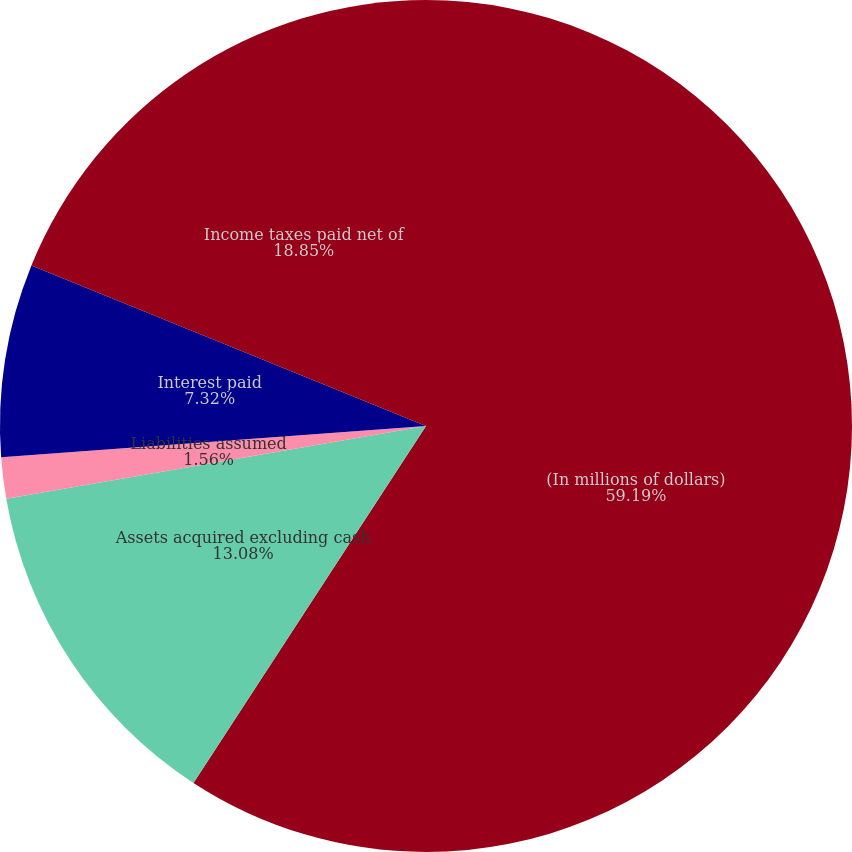<chart> <loc_0><loc_0><loc_500><loc_500><pie_chart><fcel>(In millions of dollars)<fcel>Assets acquired excluding cash<fcel>Liabilities assumed<fcel>Interest paid<fcel>Income taxes paid net of<nl><fcel>59.19%<fcel>13.08%<fcel>1.56%<fcel>7.32%<fcel>18.85%<nl></chart> 